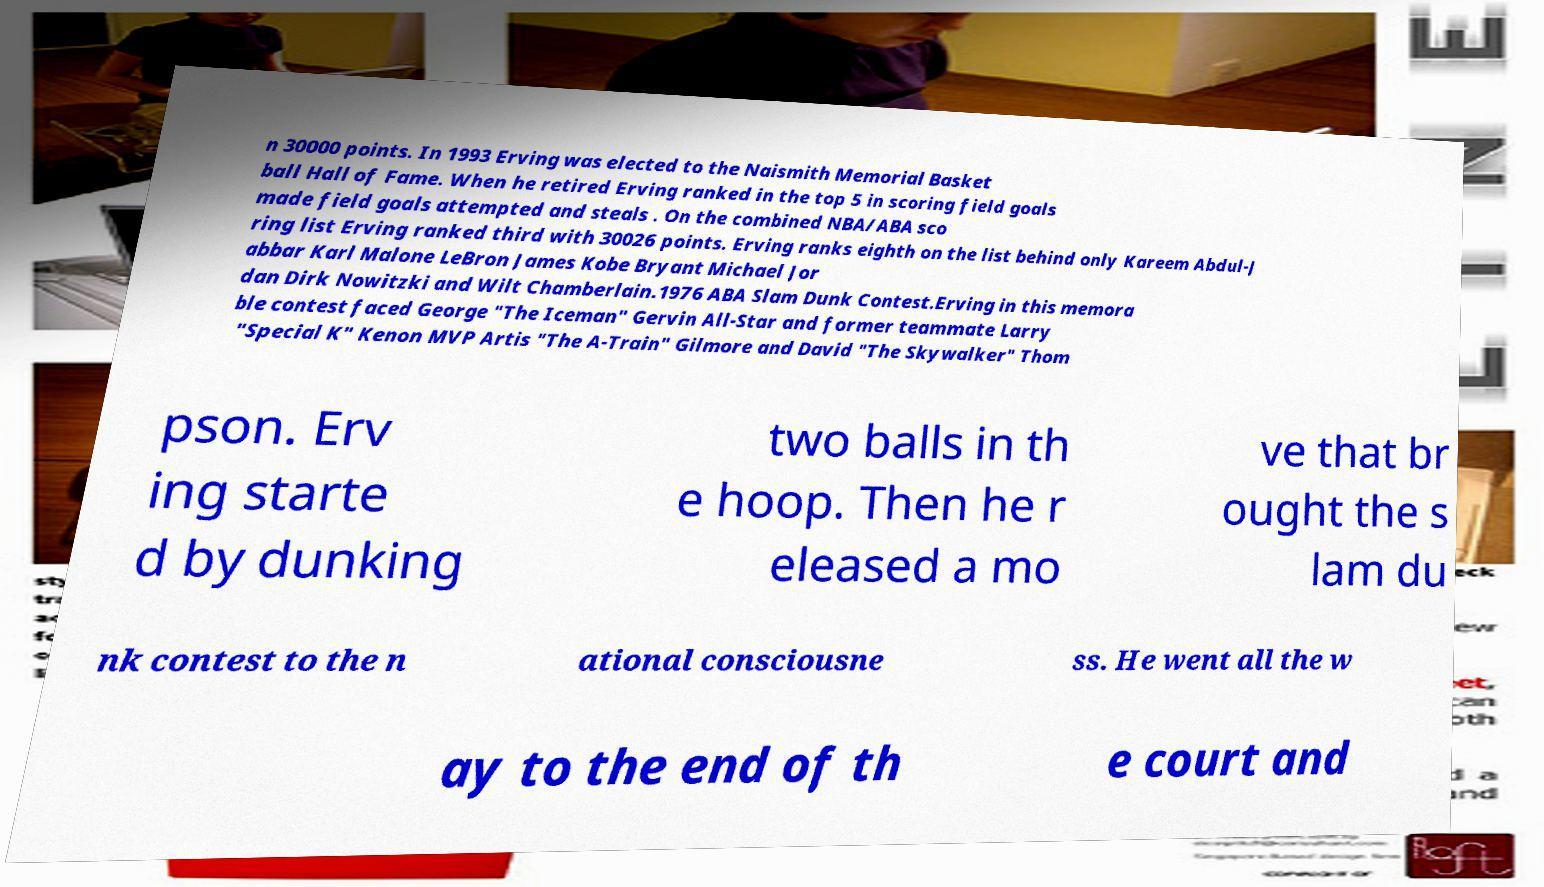I need the written content from this picture converted into text. Can you do that? n 30000 points. In 1993 Erving was elected to the Naismith Memorial Basket ball Hall of Fame. When he retired Erving ranked in the top 5 in scoring field goals made field goals attempted and steals . On the combined NBA/ABA sco ring list Erving ranked third with 30026 points. Erving ranks eighth on the list behind only Kareem Abdul-J abbar Karl Malone LeBron James Kobe Bryant Michael Jor dan Dirk Nowitzki and Wilt Chamberlain.1976 ABA Slam Dunk Contest.Erving in this memora ble contest faced George "The Iceman" Gervin All-Star and former teammate Larry "Special K" Kenon MVP Artis "The A-Train" Gilmore and David "The Skywalker" Thom pson. Erv ing starte d by dunking two balls in th e hoop. Then he r eleased a mo ve that br ought the s lam du nk contest to the n ational consciousne ss. He went all the w ay to the end of th e court and 